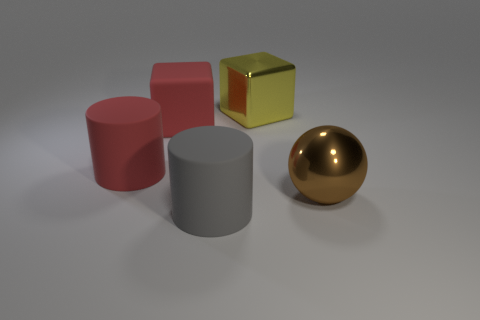Is there another large ball that has the same material as the brown ball?
Your response must be concise. No. The brown thing has what shape?
Your response must be concise. Sphere. What color is the big cube that is the same material as the red cylinder?
Your response must be concise. Red. What number of yellow objects are large rubber cubes or small things?
Provide a short and direct response. 0. Is the number of red shiny cubes greater than the number of big rubber things?
Offer a very short reply. No. How many things are large shiny things that are behind the brown metal object or big things that are in front of the yellow thing?
Your response must be concise. 5. What is the color of the shiny ball that is the same size as the yellow shiny cube?
Provide a short and direct response. Brown. Do the large brown ball and the red cube have the same material?
Keep it short and to the point. No. What is the block that is to the right of the large rubber object that is in front of the red rubber cylinder made of?
Ensure brevity in your answer.  Metal. Is the number of big red rubber cylinders on the left side of the big brown sphere greater than the number of big cyan metal cylinders?
Offer a terse response. Yes. 